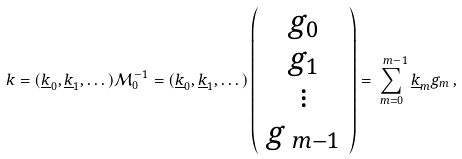Convert formula to latex. <formula><loc_0><loc_0><loc_500><loc_500>k = ( \underline { k } _ { 0 } , \underline { k } _ { 1 } , \dots ) \mathcal { M } _ { 0 } ^ { - 1 } = ( \underline { k } _ { 0 } , \underline { k } _ { 1 } , \dots ) \left ( \begin{array} { c } g _ { 0 } \\ g _ { 1 } \\ \vdots \\ g _ { \ m - 1 } \end{array} \right ) = \sum _ { m = 0 } ^ { \ m - 1 } \underline { k } _ { m } g _ { m } \, ,</formula> 